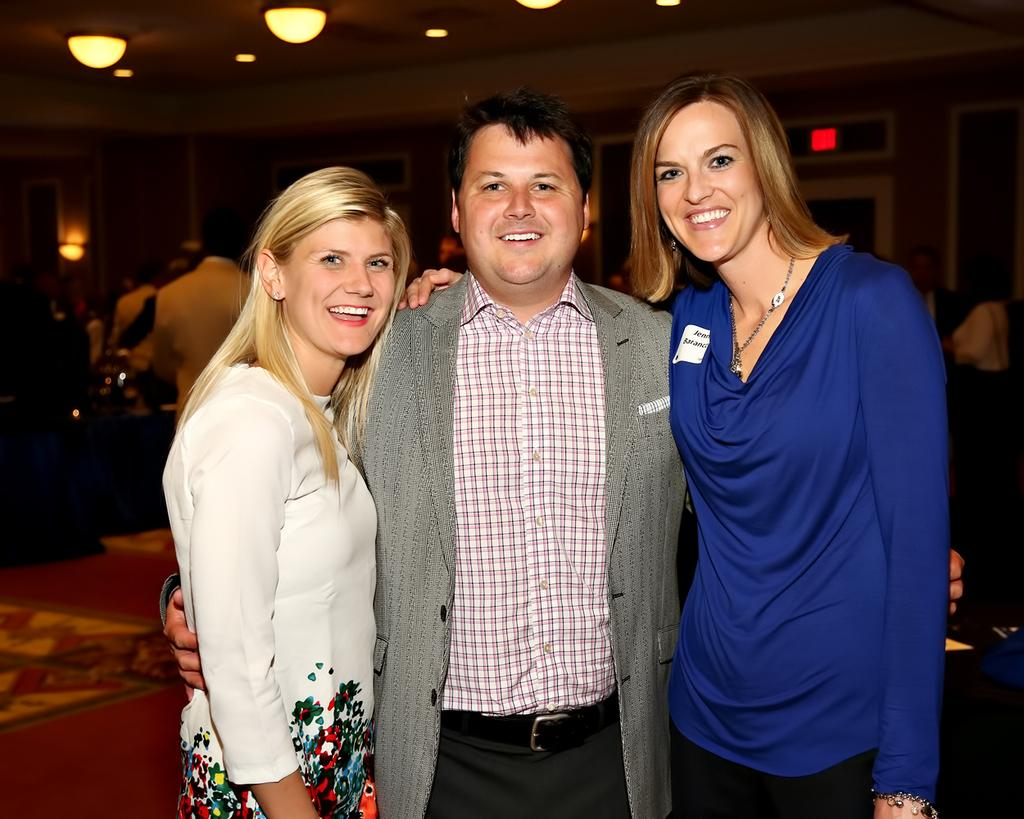How many people are in the image? There are three people standing in the image. What are the three people doing? The three people are posing for a photo. Can you describe the background of the image? There are people visible in the background of the image. What can be seen on the ceiling in the image? There are lights attached to the ceiling in the image. What type of advertisement can be seen on the wall in the image? There is no advertisement present on the wall in the image. What type of battle is taking place in the image? There is no battle depicted in the image; it features three people posing for a photo. 